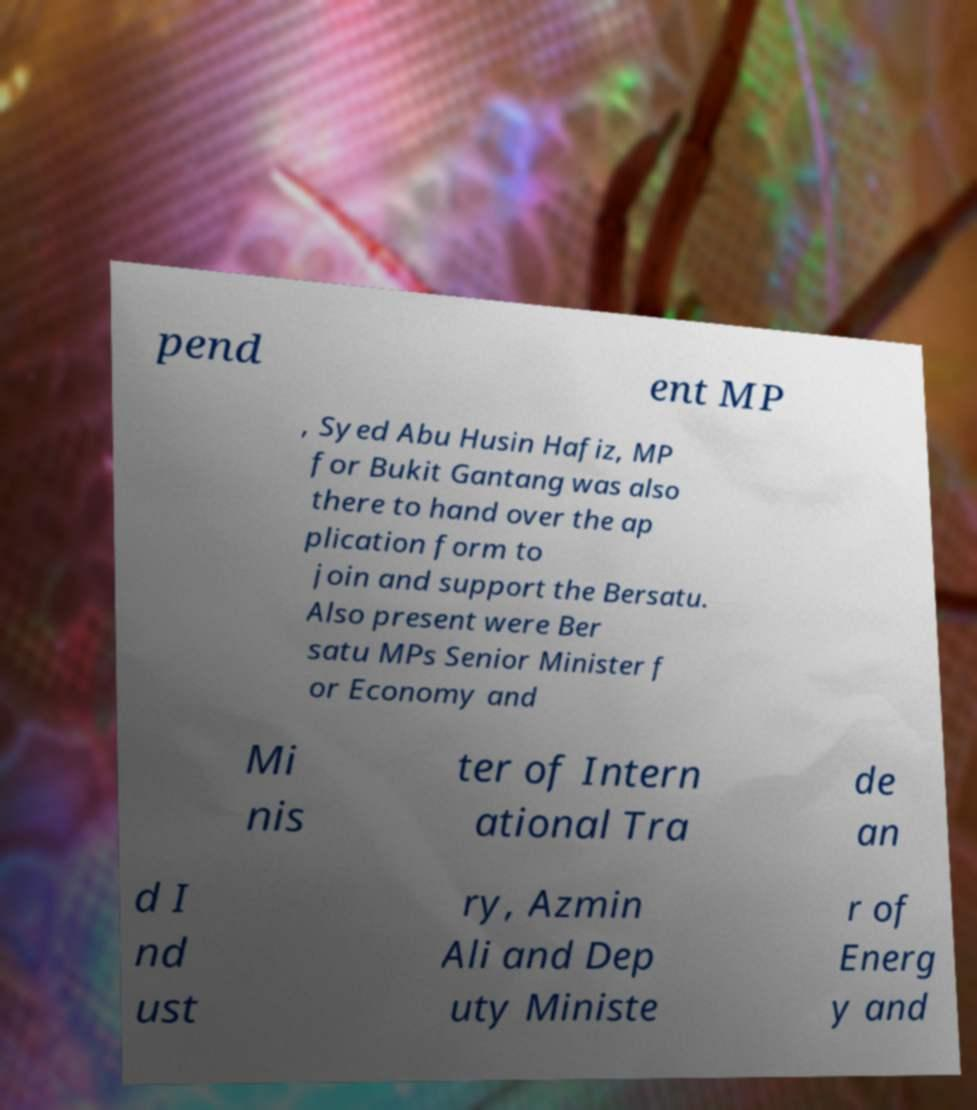For documentation purposes, I need the text within this image transcribed. Could you provide that? pend ent MP , Syed Abu Husin Hafiz, MP for Bukit Gantang was also there to hand over the ap plication form to join and support the Bersatu. Also present were Ber satu MPs Senior Minister f or Economy and Mi nis ter of Intern ational Tra de an d I nd ust ry, Azmin Ali and Dep uty Ministe r of Energ y and 